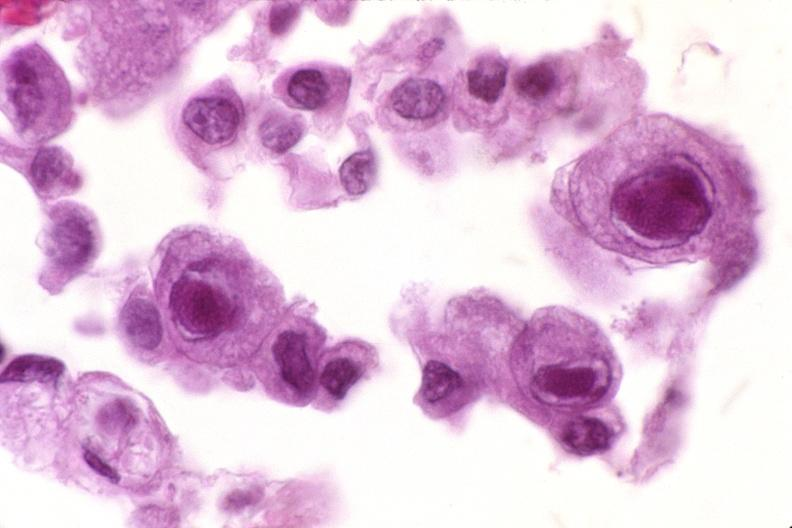s respiratory present?
Answer the question using a single word or phrase. Yes 